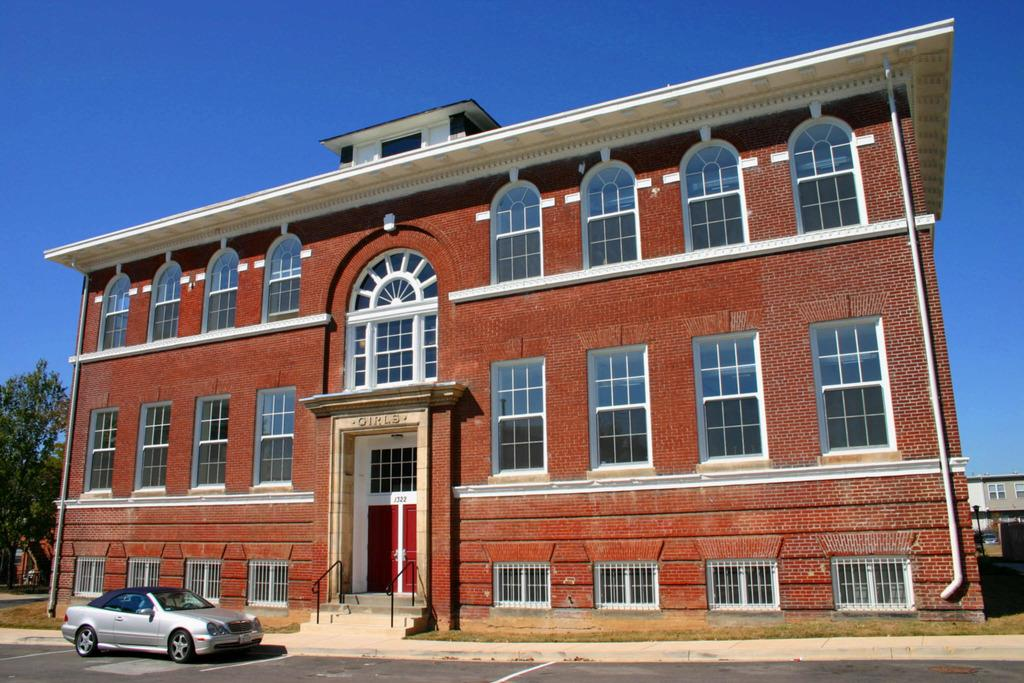What is on the road in the image? There is a car on the road in the image. What can be seen in the background of the image? There is a building with windows in the image, and there are trees on the left side of the image. What features does the building have? The building has a door and stairs in the image. What is present on the right side of the image? There are buildings on the right side of the image. Are there any cows visible in the image? No, there are no cows present in the image. Can you see any steam coming from the building in the image? No, there is no steam visible in the image. 